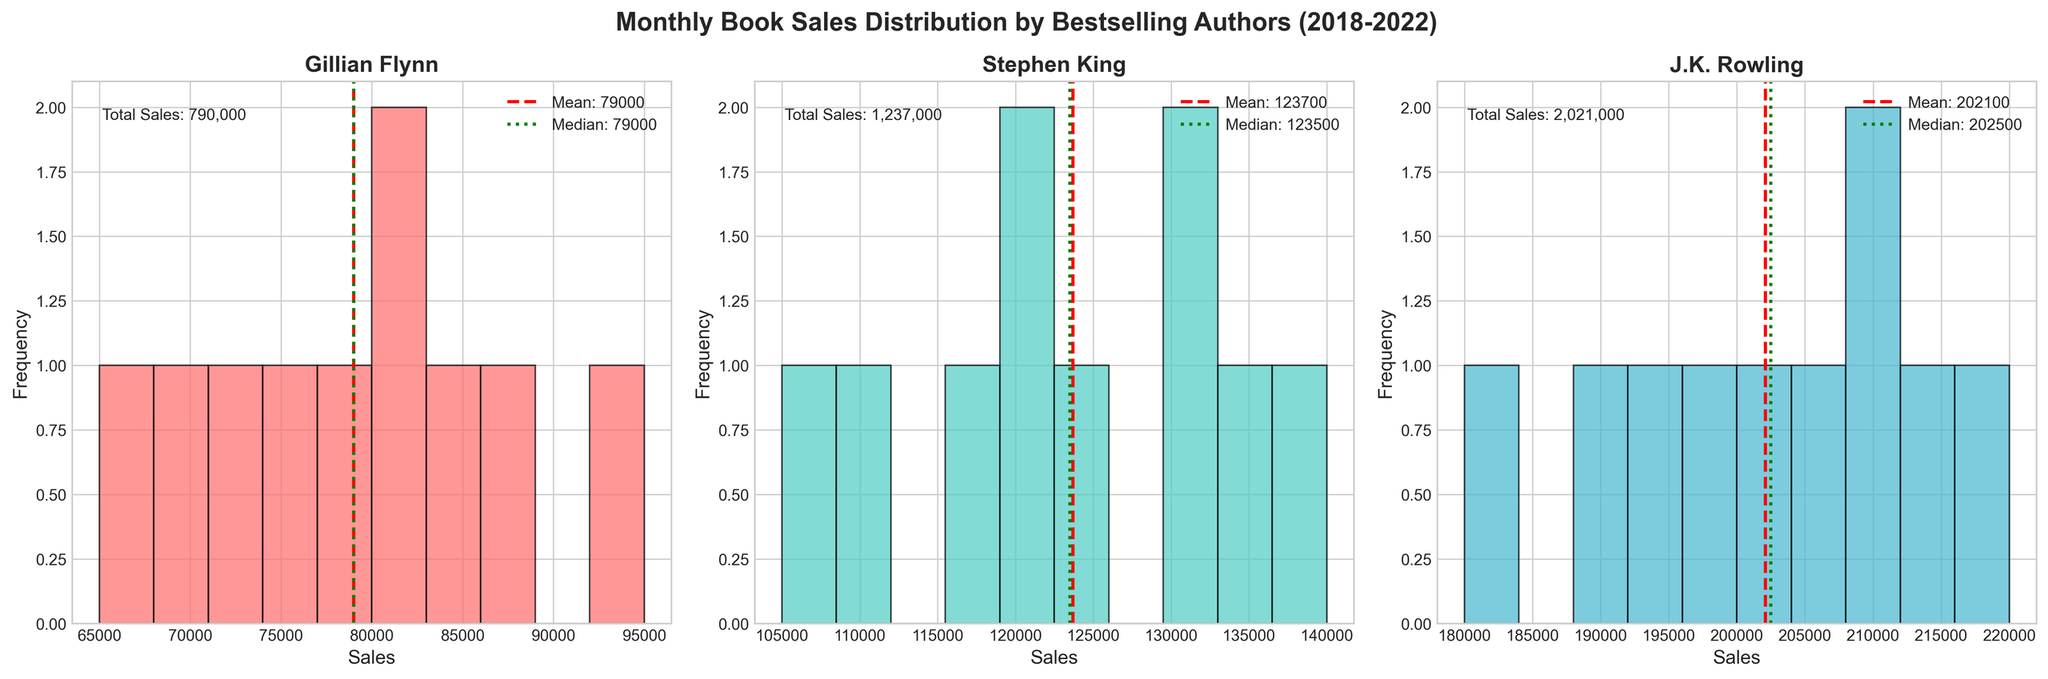What is the title of the figure? The title can be found at the top of the figure, which summarizes the main subject being visualized.
Answer: Monthly Book Sales Distribution by Bestselling Authors (2018-2022) How many subplots are there, and which authors do they represent? The figure contains three subplots, each titled with an author's name. These titles can be seen above each subplot.
Answer: Three subplots representing Gillian Flynn, Stephen King, and J.K. Rowling What is the color of the histogram bars for Gillian Flynn? The histogram bars for Gillian Flynn are filled with a unique color that distinguishes them from other authors. This color is visible in the subplot.
Answer: Light pink What are the mean and median sales for Stephen King? The mean and median sales values are indicated by dashed lines (red) and dotted lines (green), respectively, in Stephen King's subplot, with the values labeled next to the lines.
Answer: Mean: 123300, Median: 120000 Which author has the highest total sales over the 5-year period? The total sales for each author are annotated in their respective subplot. By comparing these annotations, the author with the highest total sales can be identified.
Answer: J.K. Rowling Which author exhibits the widest range of monthly sales? By observing the spread of the histogram bars in each author's subplot, we can determine which author has the largest range between their lowest and highest monthly sales figures.
Answer: J.K. Rowling How does the distribution of sales for Gillian Flynn compare to J.K. Rowling? To compare the sales distributions, examine the spread, concentration, and frequency of the histogram bars in both subplots. This includes looking at the central tendency and spread of data points.
Answer: Gillian Flynn's sales are more evenly distributed and are generally lower compared to J.K. Rowling's higher and more spread out sales Are the mean and median sales for J.K. Rowling close to each other? Look at the red dashed line (mean) and the green dotted line (median) in J.K. Rowling's subplot to see if they are positioned close together, which indicates similarity.
Answer: Yes In which author's histogram is the frequency of lower sales values more prevalent? By observing the concentration of histogram bars towards the lower end of the sales axis in each subplot, we can determine which author has more instances of lower sales values.
Answer: Gillian Flynn Which author shows a more consistent sales performance over the periods? Consistency in sales performance can be inferred from the histogram shape and the central tendency indicators like mean and median. A narrower spread and closely aligned mean and median usually indicate consistency.
Answer: Stephen King 